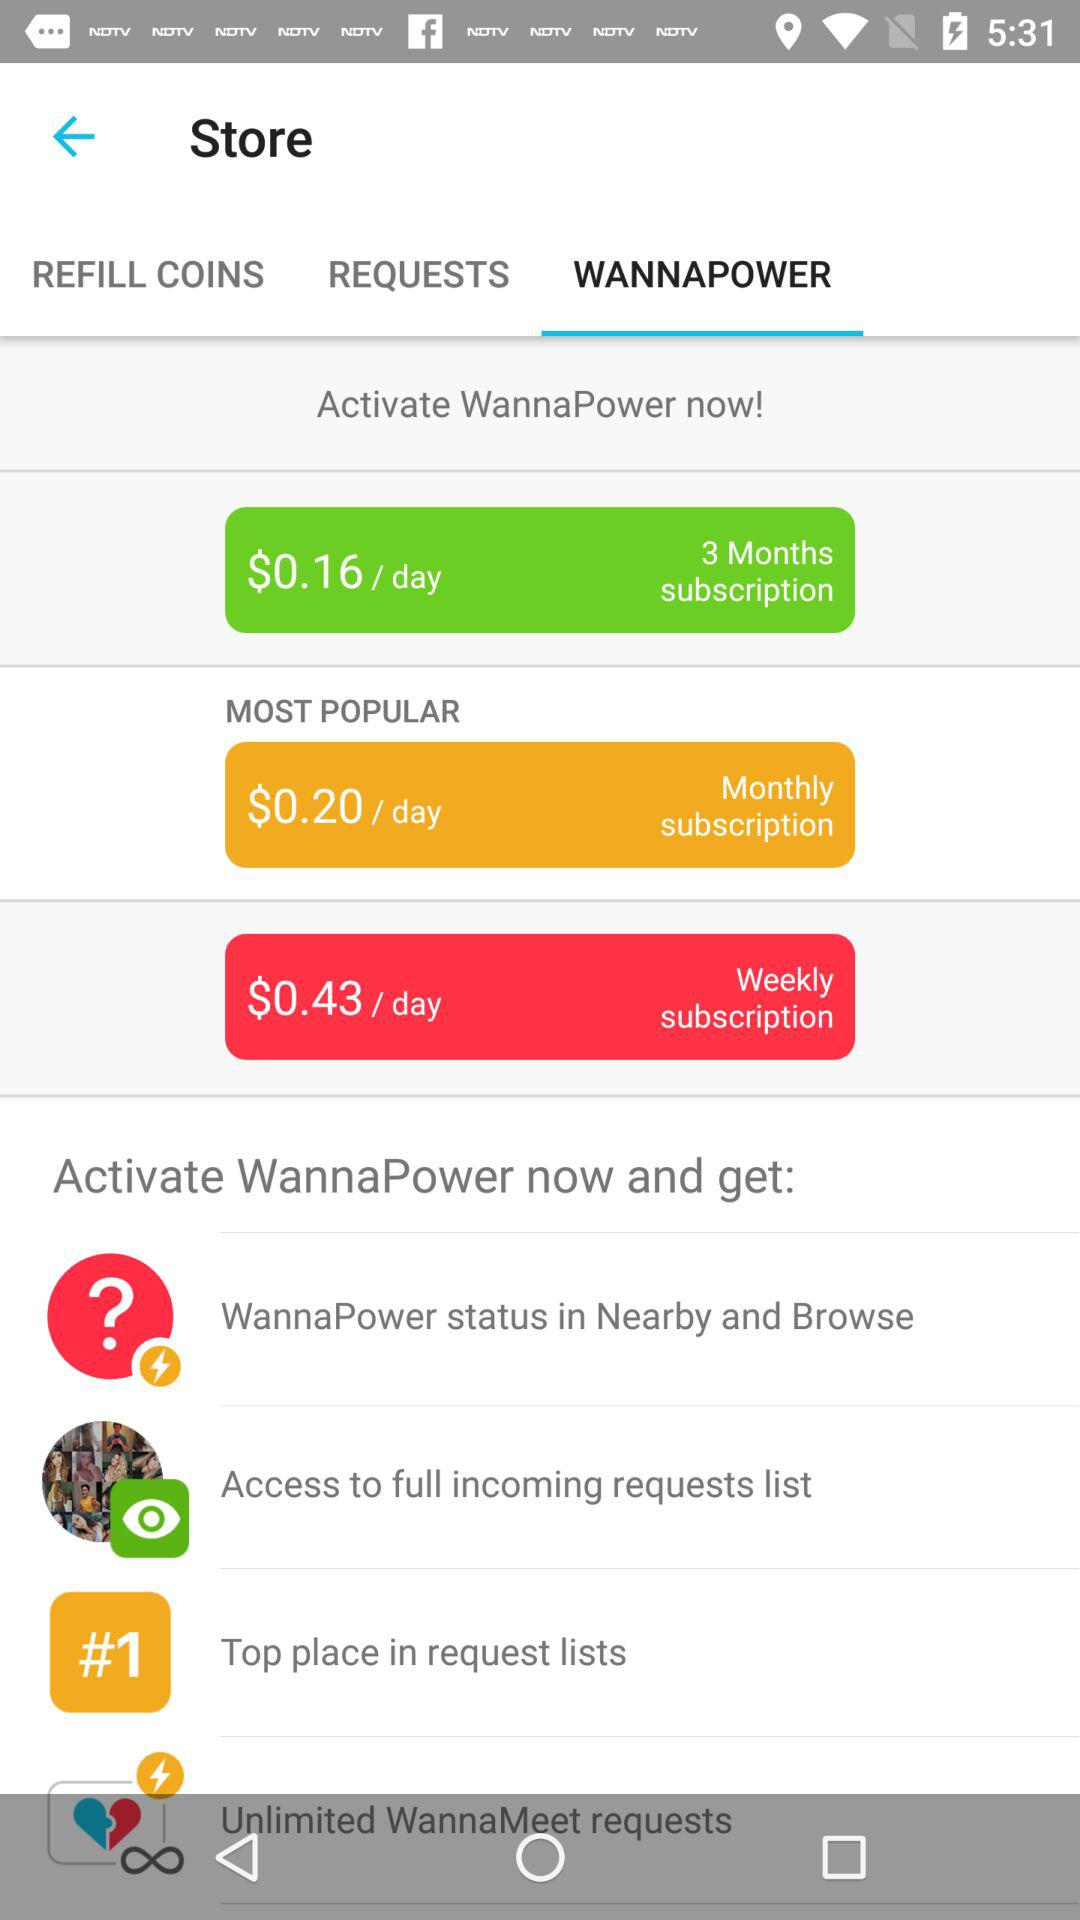How much more does the weekly subscription cost than the monthly subscription?
Answer the question using a single word or phrase. $0.23 